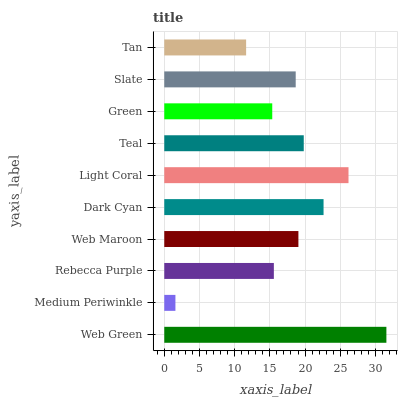Is Medium Periwinkle the minimum?
Answer yes or no. Yes. Is Web Green the maximum?
Answer yes or no. Yes. Is Rebecca Purple the minimum?
Answer yes or no. No. Is Rebecca Purple the maximum?
Answer yes or no. No. Is Rebecca Purple greater than Medium Periwinkle?
Answer yes or no. Yes. Is Medium Periwinkle less than Rebecca Purple?
Answer yes or no. Yes. Is Medium Periwinkle greater than Rebecca Purple?
Answer yes or no. No. Is Rebecca Purple less than Medium Periwinkle?
Answer yes or no. No. Is Web Maroon the high median?
Answer yes or no. Yes. Is Slate the low median?
Answer yes or no. Yes. Is Light Coral the high median?
Answer yes or no. No. Is Teal the low median?
Answer yes or no. No. 